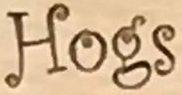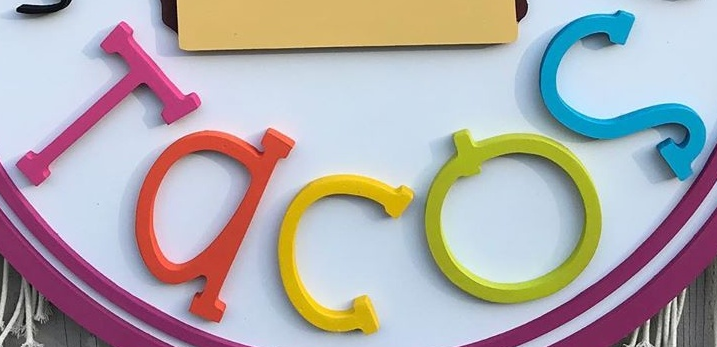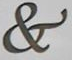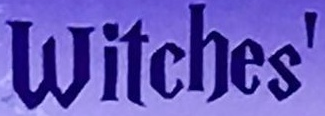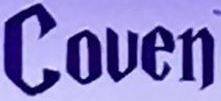Read the text content from these images in order, separated by a semicolon. Hogs; Tacos; &; Witches'; Couen 